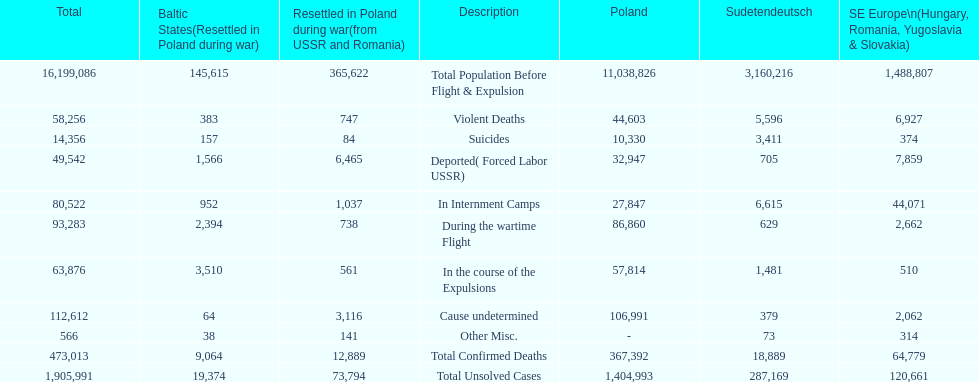Which region had the least total of unsolved cases? Baltic States(Resettled in Poland during war). 